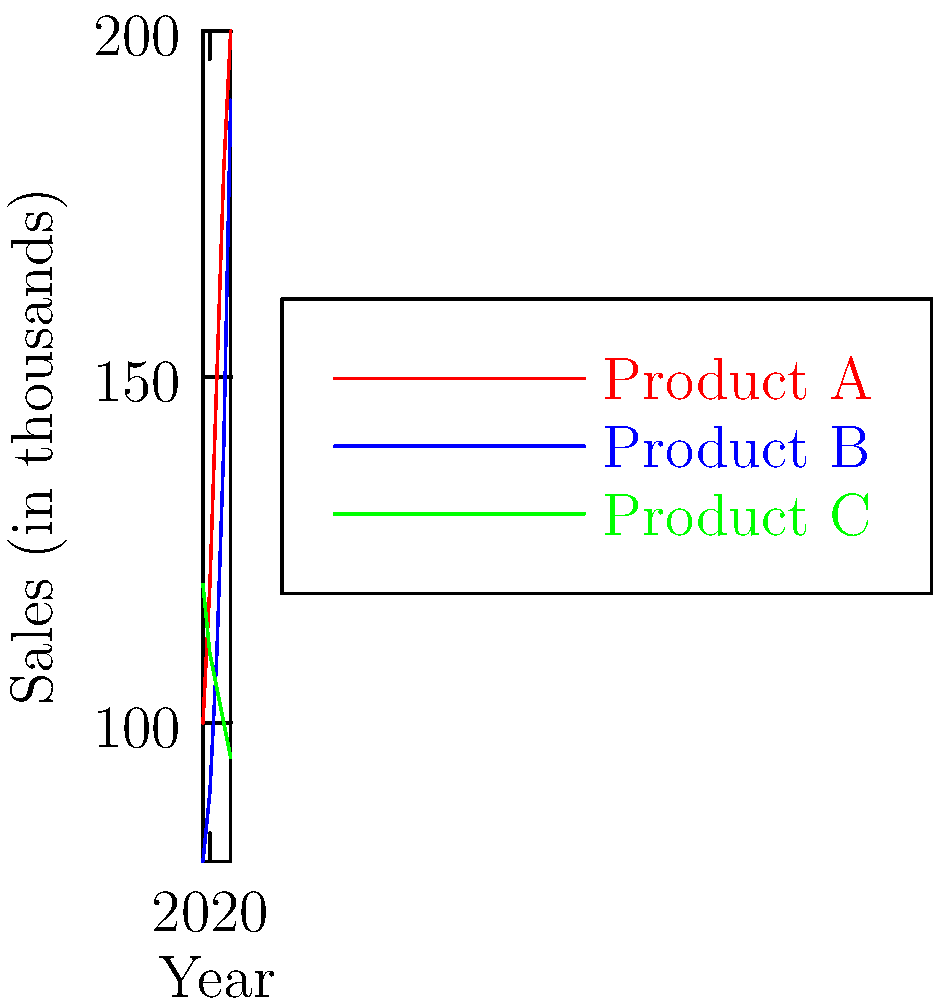As a retail brand manager, you're analyzing sales trends for three product lines over the past five years. Based on the line graph, which product line shows the most promising growth potential for expanding into diverse communities, and what is its average year-over-year growth rate? To determine the most promising product line and calculate its average year-over-year growth rate:

1. Analyze the trends:
   Product A: Steady growth
   Product B: Accelerating growth, especially in recent years
   Product C: Declining sales

2. Product B shows the most promising growth potential.

3. Calculate Product B's year-over-year growth rates:
   2019 to 2020: $(90-80)/80 \times 100\% = 12.5\%$
   2020 to 2021: $(110-90)/90 \times 100\% = 22.2\%$
   2021 to 2022: $(140-110)/110 \times 100\% = 27.3\%$
   2022 to 2023: $(190-140)/140 \times 100\% = 35.7\%$

4. Calculate the average growth rate:
   $\text{Average} = (12.5\% + 22.2\% + 27.3\% + 35.7\%) / 4 = 24.425\%$

5. Round to the nearest tenth:
   $24.4\%$

Therefore, Product B is the most promising, with an average year-over-year growth rate of 24.4%.
Answer: Product B, 24.4% 